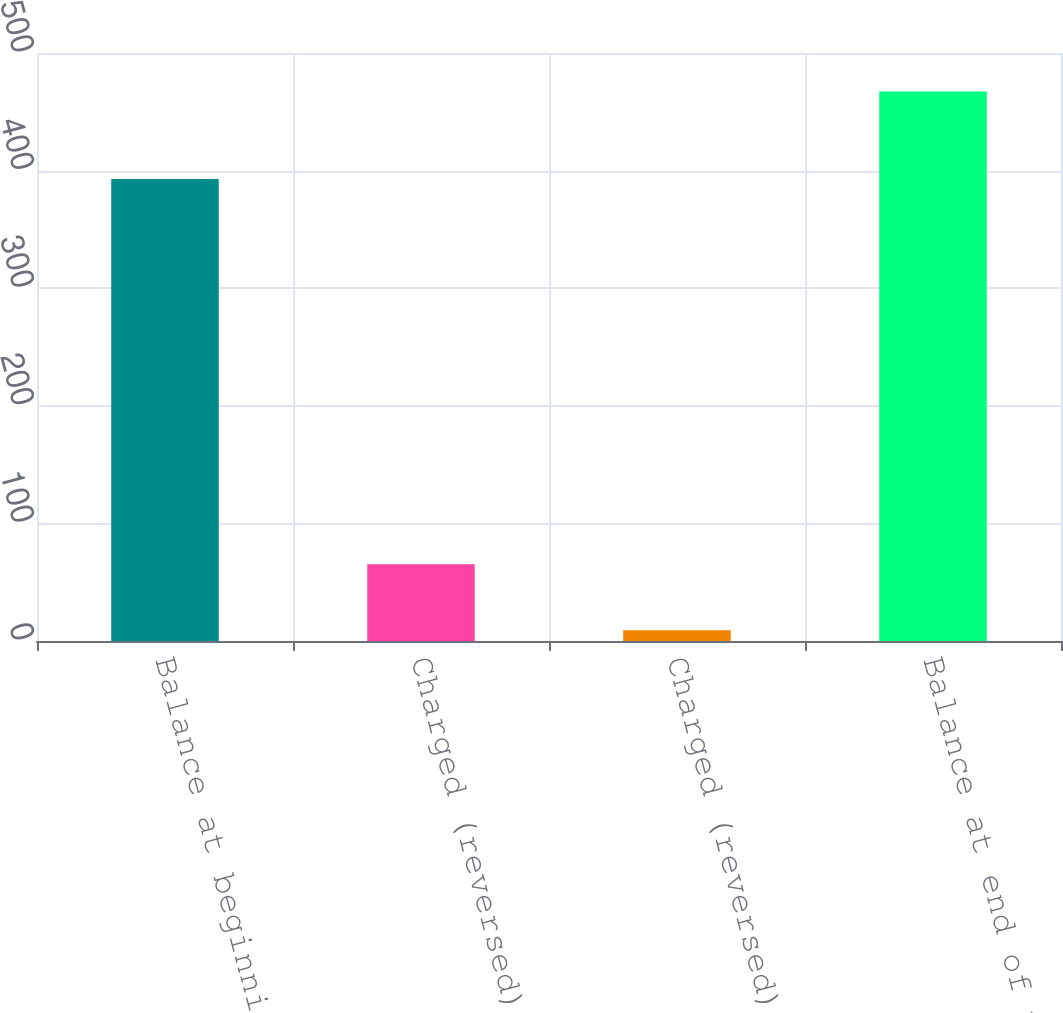Convert chart. <chart><loc_0><loc_0><loc_500><loc_500><bar_chart><fcel>Balance at beginning of period<fcel>Charged (reversed) to costs<fcel>Charged (reversed) to gross<fcel>Balance at end of period<nl><fcel>392.9<fcel>65.2<fcel>9.2<fcel>467.3<nl></chart> 